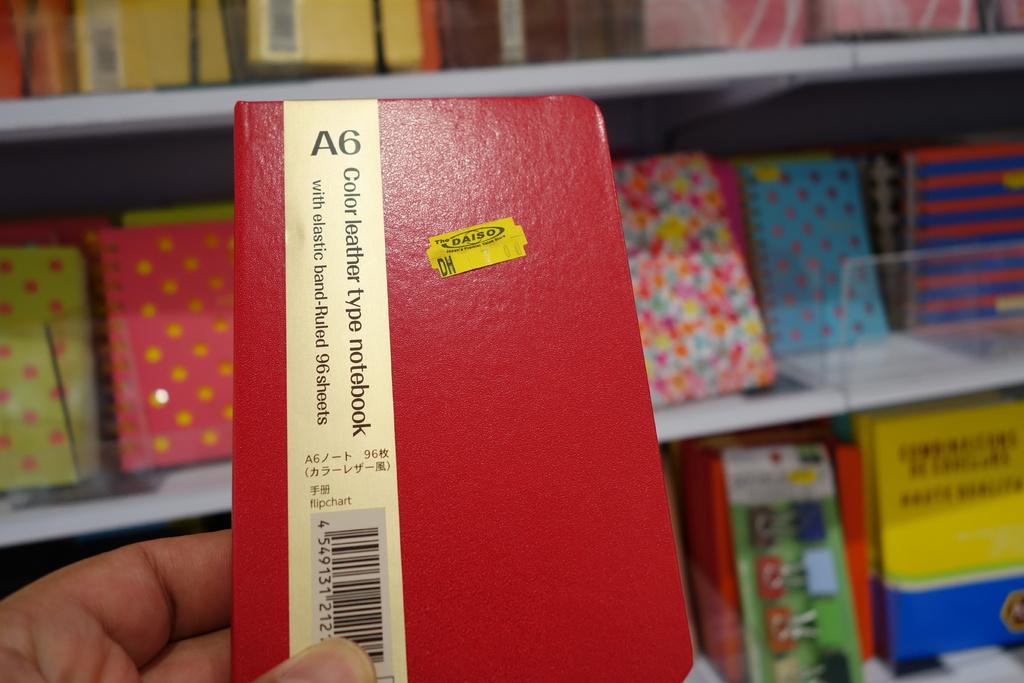What size paper is in the notebook?
Offer a very short reply. A6. 